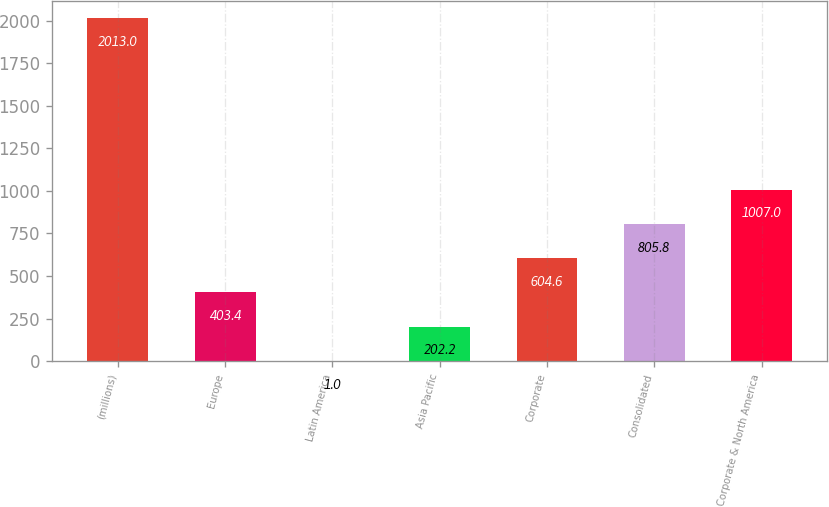Convert chart to OTSL. <chart><loc_0><loc_0><loc_500><loc_500><bar_chart><fcel>(millions)<fcel>Europe<fcel>Latin America<fcel>Asia Pacific<fcel>Corporate<fcel>Consolidated<fcel>Corporate & North America<nl><fcel>2013<fcel>403.4<fcel>1<fcel>202.2<fcel>604.6<fcel>805.8<fcel>1007<nl></chart> 